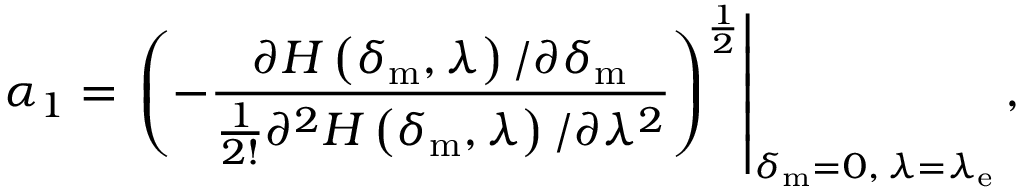<formula> <loc_0><loc_0><loc_500><loc_500>\alpha _ { 1 } = \left ( - \frac { \partial H \left ( \delta _ { m } , \lambda \right ) / \partial \delta _ { m } } { \frac { 1 } { 2 ! } \partial ^ { 2 } H \left ( \delta _ { m } , \lambda \right ) / \partial \lambda ^ { 2 } } \right ) ^ { \frac { 1 } { 2 } } \right | _ { \delta _ { m } = 0 , \, \lambda = \lambda _ { e } } ,</formula> 